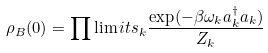Convert formula to latex. <formula><loc_0><loc_0><loc_500><loc_500>\rho _ { B } ( 0 ) = \prod \lim i t s _ { k } \frac { \exp ( - \beta \omega _ { k } a _ { k } ^ { \dag } a _ { k } ) } { Z _ { k } }</formula> 